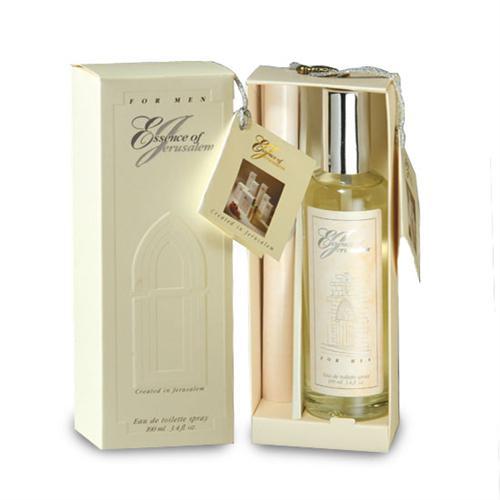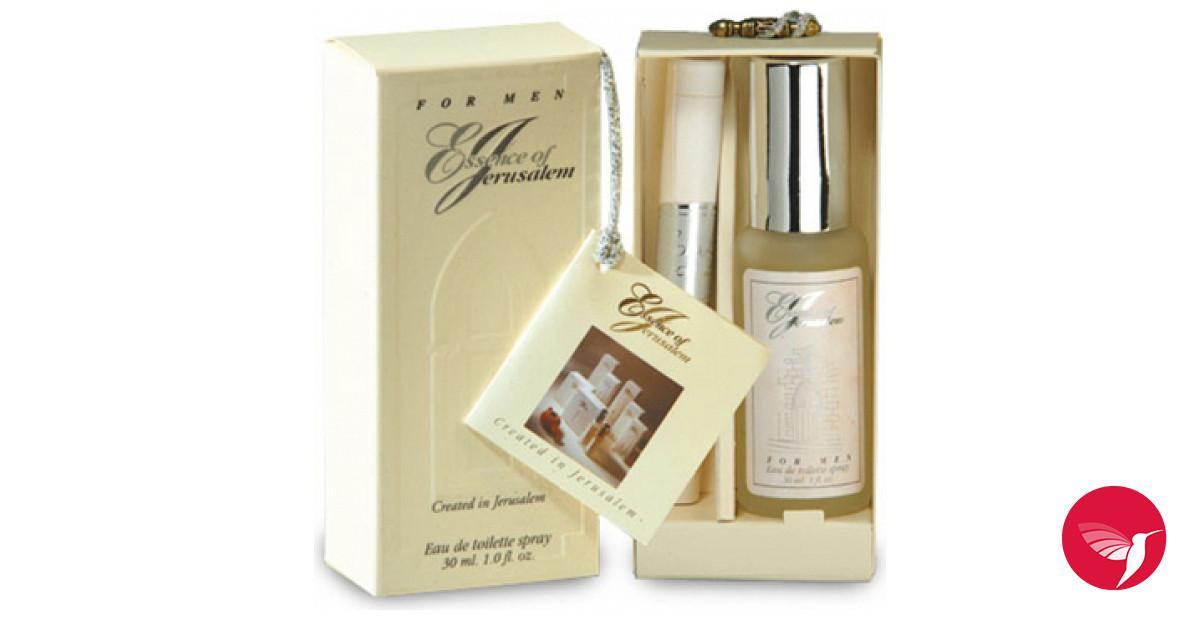The first image is the image on the left, the second image is the image on the right. For the images displayed, is the sentence "Each perfume set includes long, narrow cylinder and a bottle with a metal cap." factually correct? Answer yes or no. Yes. 